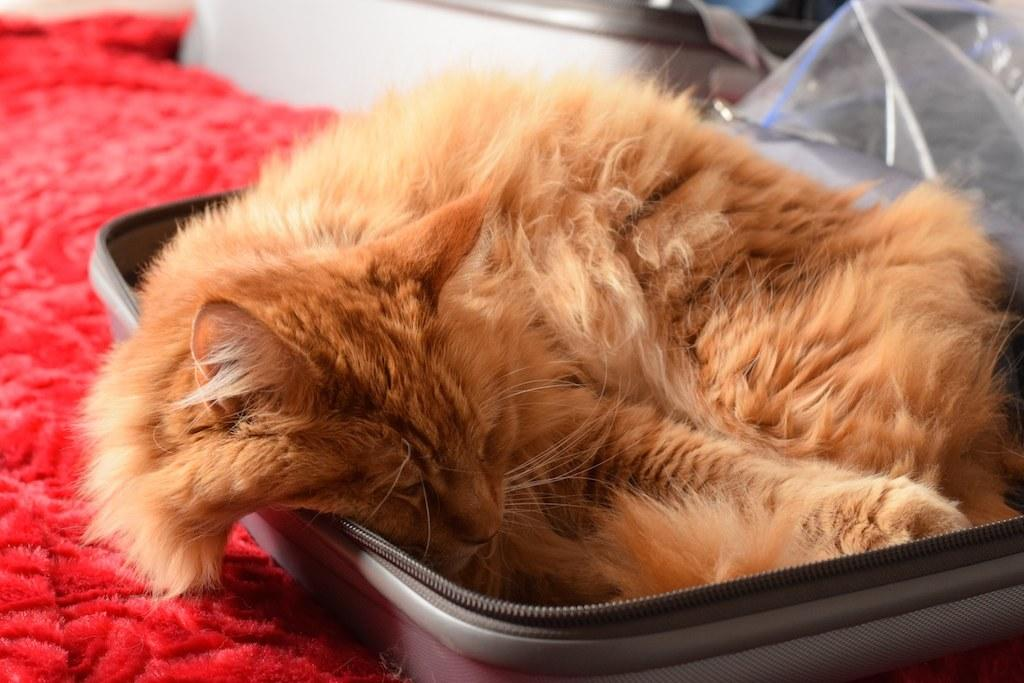What type of animal is in the image? There is a cat in the image. Where is the cat located? The cat is lying in a suitcase. What is at the bottom of the suitcase? There is a bed sheet at the bottom of the suitcase. Can you describe the background of the image? The background of the image is blurry. What is on the right side of the image? There is a plastic cover on the right side of the image. What type of request does the cat make to the daughter in the image? There is no daughter present in the image, and the cat does not make any requests. 